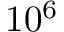Convert formula to latex. <formula><loc_0><loc_0><loc_500><loc_500>1 0 ^ { 6 }</formula> 